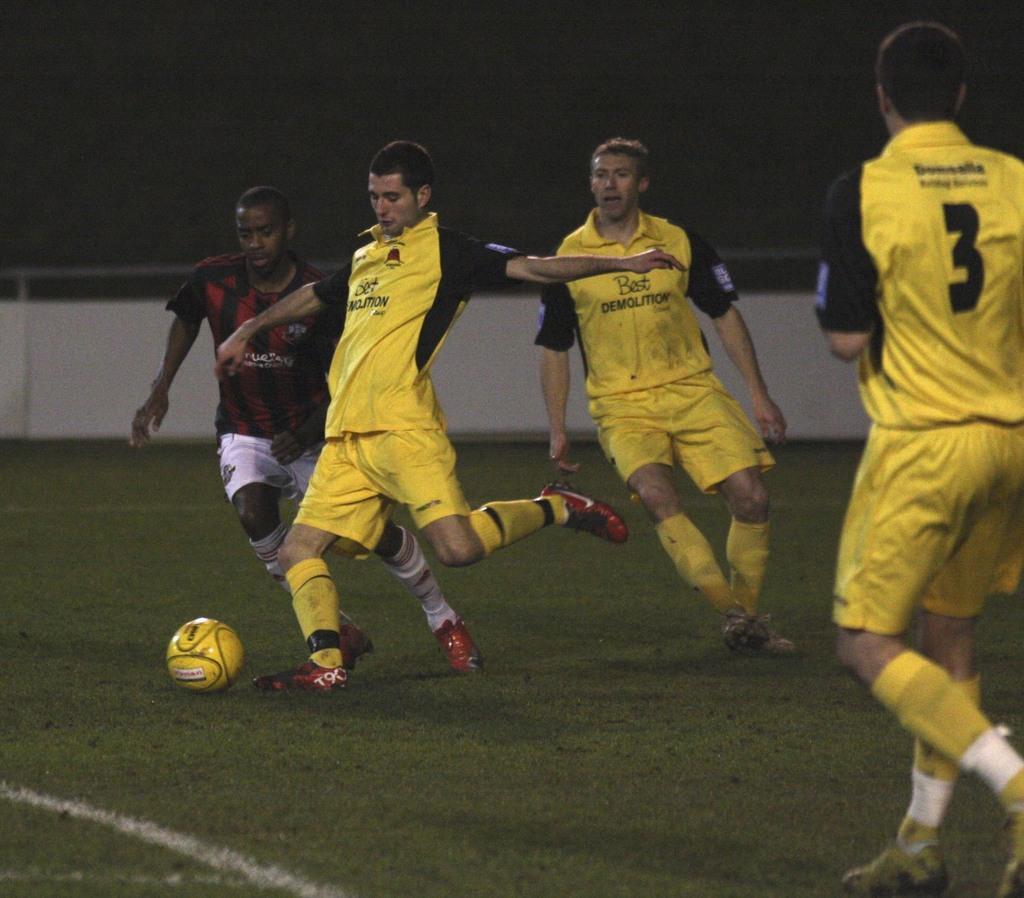What is the number of the player on the far right?
Your answer should be compact. 3. What team do they play for?
Offer a very short reply. Best demolition. 